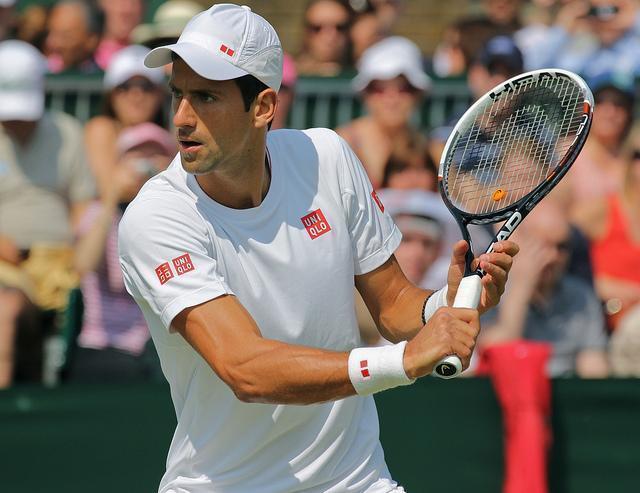How many people can be seen?
Give a very brief answer. 10. 